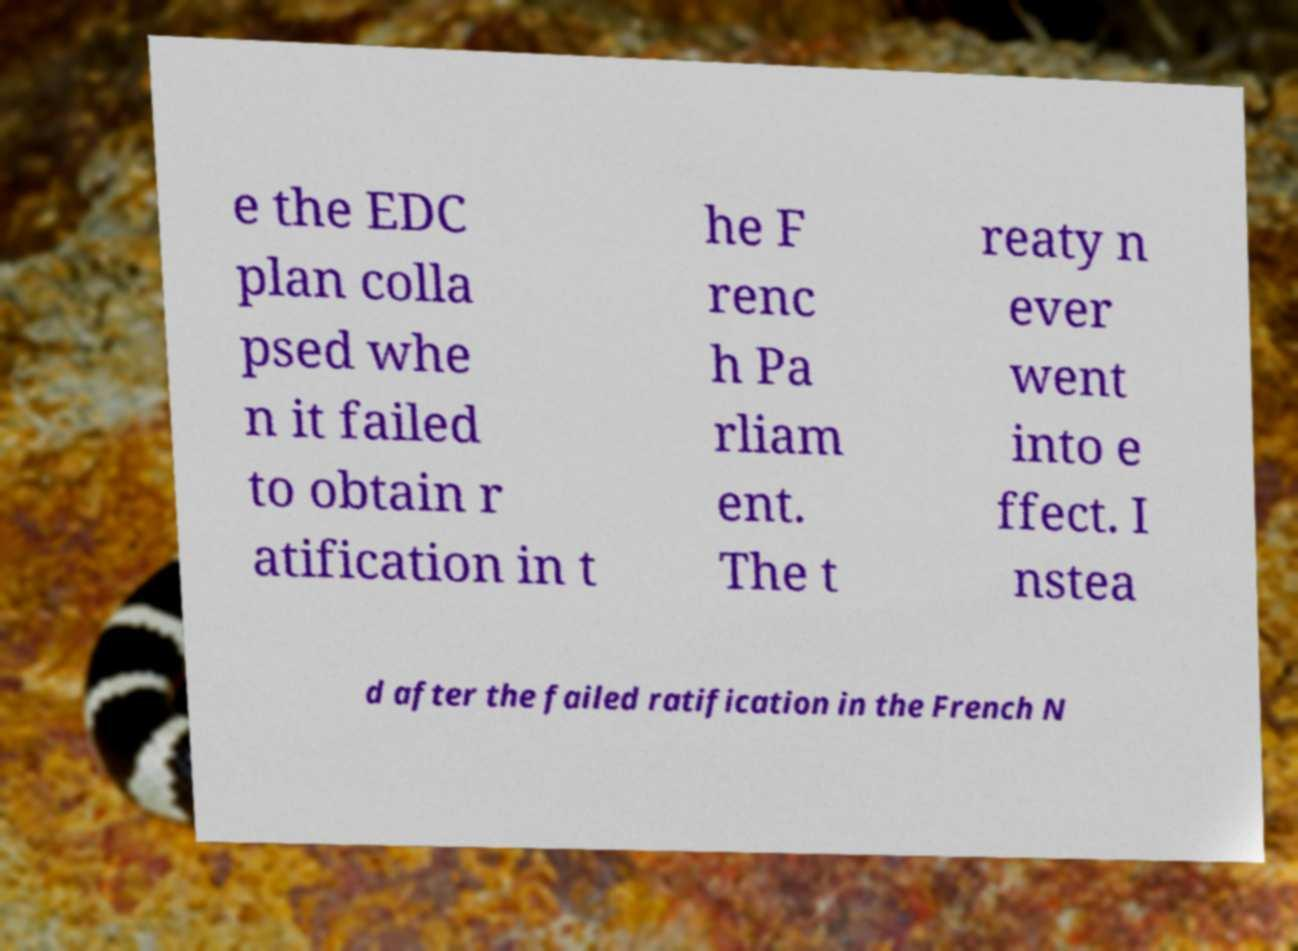Please read and relay the text visible in this image. What does it say? e the EDC plan colla psed whe n it failed to obtain r atification in t he F renc h Pa rliam ent. The t reaty n ever went into e ffect. I nstea d after the failed ratification in the French N 